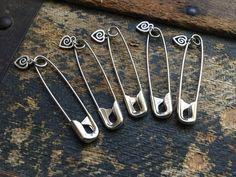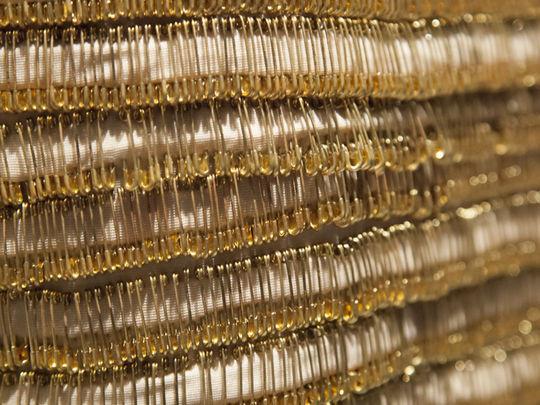The first image is the image on the left, the second image is the image on the right. Examine the images to the left and right. Is the description "At least one image in the pari has both gold and silver colored safety pins." accurate? Answer yes or no. No. 